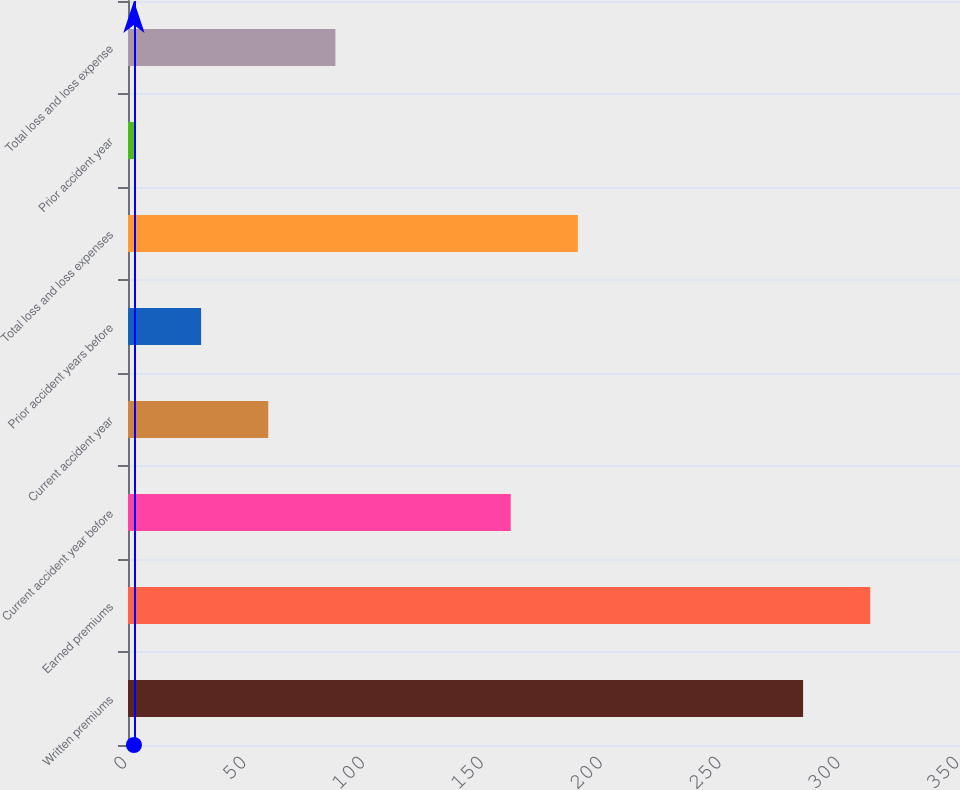Convert chart to OTSL. <chart><loc_0><loc_0><loc_500><loc_500><bar_chart><fcel>Written premiums<fcel>Earned premiums<fcel>Current accident year before<fcel>Current accident year<fcel>Prior accident years before<fcel>Total loss and loss expenses<fcel>Prior accident year<fcel>Total loss and loss expense<nl><fcel>284<fcel>312.25<fcel>161<fcel>59<fcel>30.75<fcel>189.25<fcel>2.5<fcel>87.25<nl></chart> 